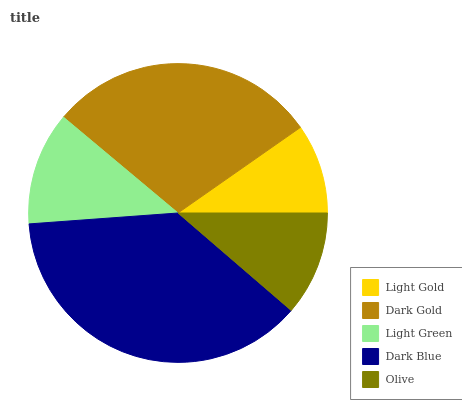Is Light Gold the minimum?
Answer yes or no. Yes. Is Dark Blue the maximum?
Answer yes or no. Yes. Is Dark Gold the minimum?
Answer yes or no. No. Is Dark Gold the maximum?
Answer yes or no. No. Is Dark Gold greater than Light Gold?
Answer yes or no. Yes. Is Light Gold less than Dark Gold?
Answer yes or no. Yes. Is Light Gold greater than Dark Gold?
Answer yes or no. No. Is Dark Gold less than Light Gold?
Answer yes or no. No. Is Light Green the high median?
Answer yes or no. Yes. Is Light Green the low median?
Answer yes or no. Yes. Is Dark Blue the high median?
Answer yes or no. No. Is Dark Gold the low median?
Answer yes or no. No. 